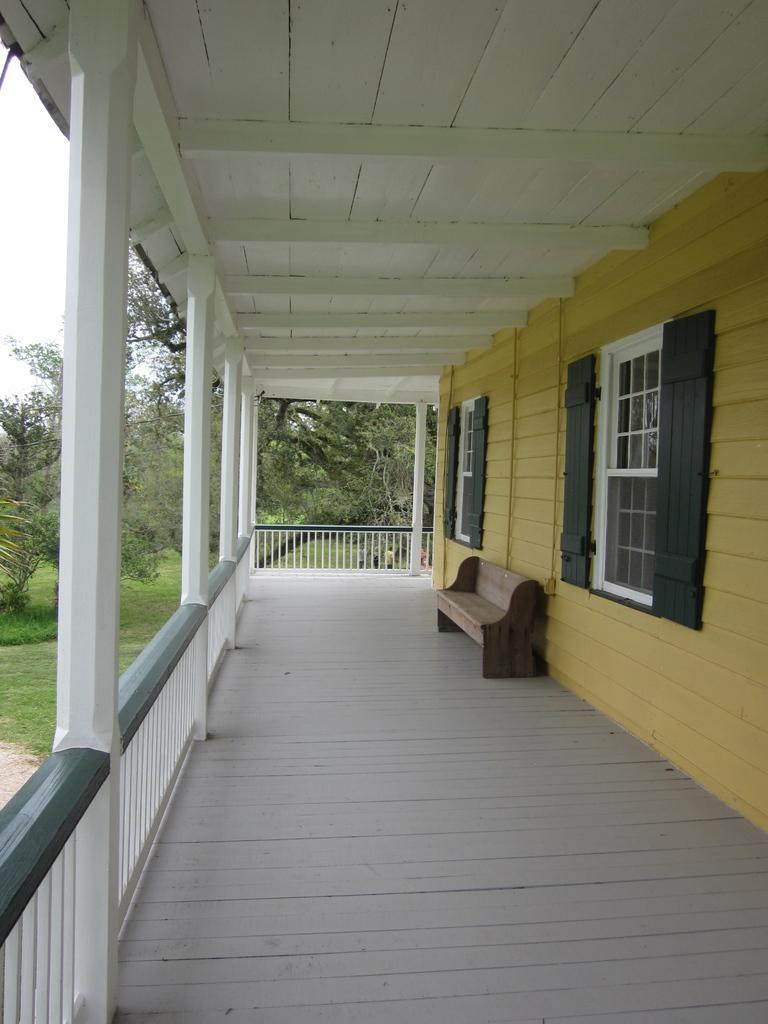Please provide a concise description of this image. In this image there are windows , bench, house,iron grills, trees,sky. 